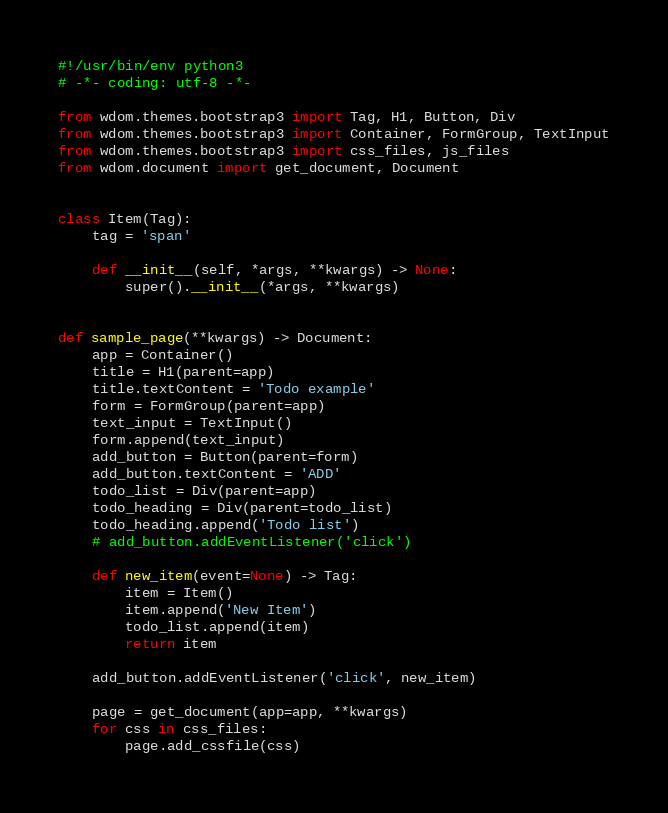<code> <loc_0><loc_0><loc_500><loc_500><_Python_>#!/usr/bin/env python3
# -*- coding: utf-8 -*-

from wdom.themes.bootstrap3 import Tag, H1, Button, Div
from wdom.themes.bootstrap3 import Container, FormGroup, TextInput
from wdom.themes.bootstrap3 import css_files, js_files
from wdom.document import get_document, Document


class Item(Tag):
    tag = 'span'

    def __init__(self, *args, **kwargs) -> None:
        super().__init__(*args, **kwargs)


def sample_page(**kwargs) -> Document:
    app = Container()
    title = H1(parent=app)
    title.textContent = 'Todo example'
    form = FormGroup(parent=app)
    text_input = TextInput()
    form.append(text_input)
    add_button = Button(parent=form)
    add_button.textContent = 'ADD'
    todo_list = Div(parent=app)
    todo_heading = Div(parent=todo_list)
    todo_heading.append('Todo list')
    # add_button.addEventListener('click')

    def new_item(event=None) -> Tag:
        item = Item()
        item.append('New Item')
        todo_list.append(item)
        return item

    add_button.addEventListener('click', new_item)

    page = get_document(app=app, **kwargs)
    for css in css_files:
        page.add_cssfile(css)</code> 